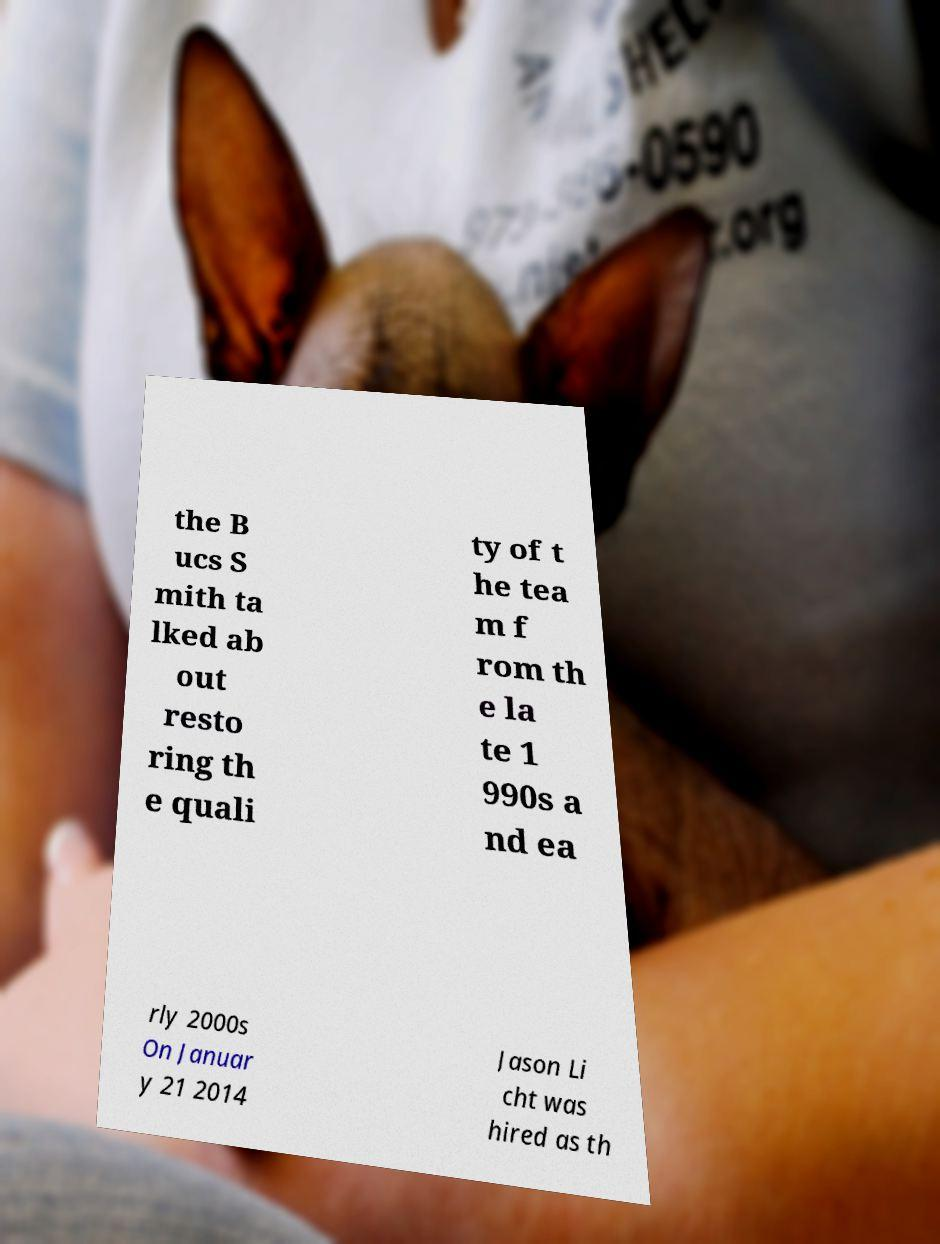Could you assist in decoding the text presented in this image and type it out clearly? the B ucs S mith ta lked ab out resto ring th e quali ty of t he tea m f rom th e la te 1 990s a nd ea rly 2000s On Januar y 21 2014 Jason Li cht was hired as th 